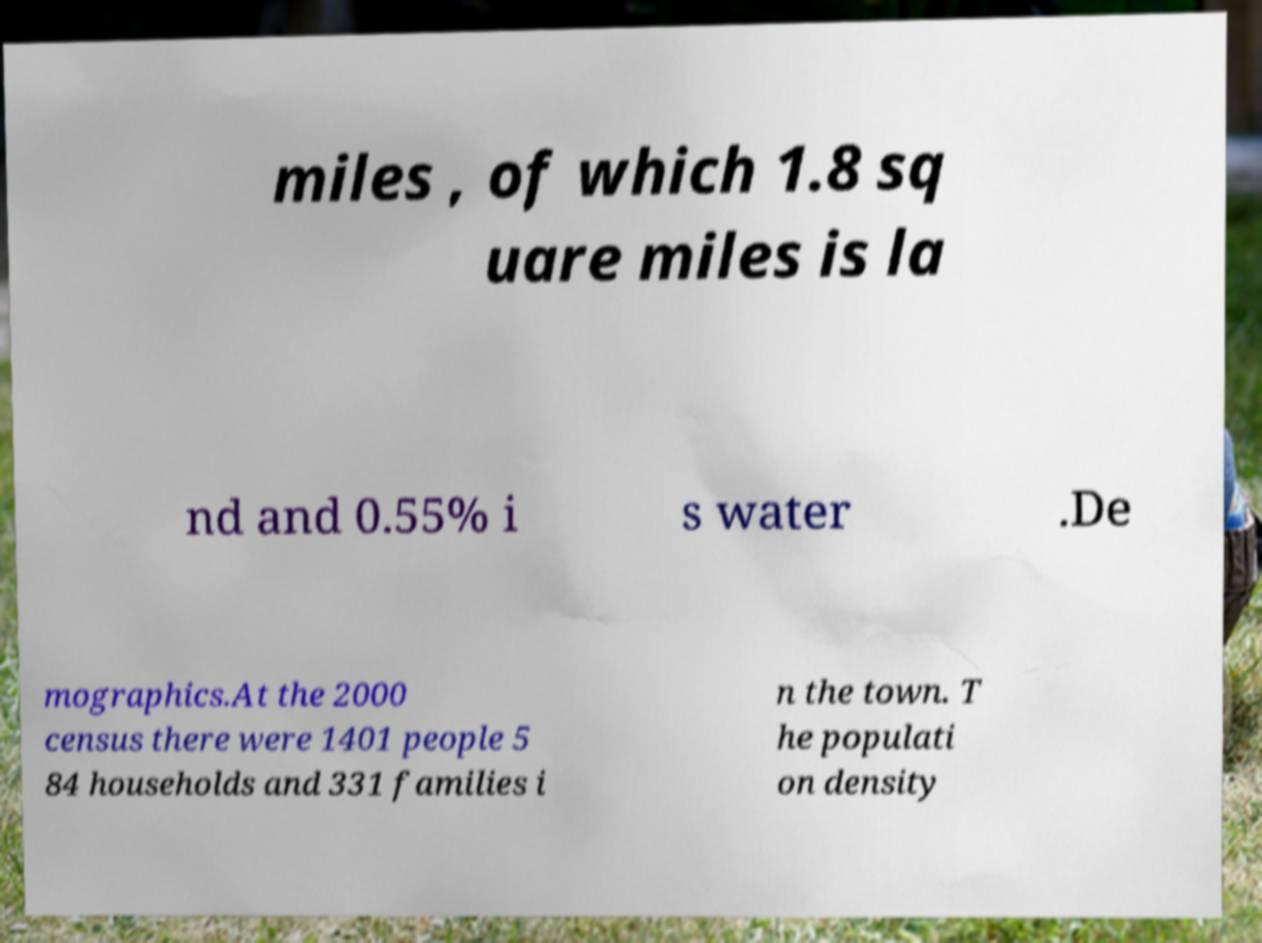Please read and relay the text visible in this image. What does it say? miles , of which 1.8 sq uare miles is la nd and 0.55% i s water .De mographics.At the 2000 census there were 1401 people 5 84 households and 331 families i n the town. T he populati on density 